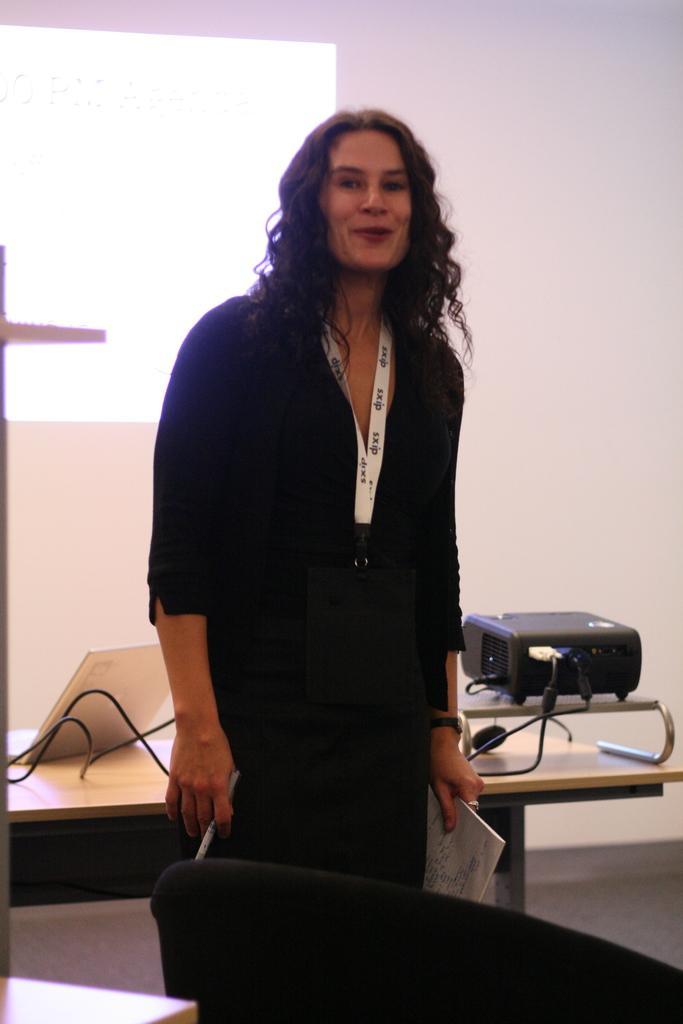Describe this image in one or two sentences. This picture is taken inside a room. There is a woman standing and holding pen and paper. She is dressed in black and she is wearing identity card. In front of her there is a chair. Behind her there is table and on the table there is laptop, cables and projector. In the background there is wall. 